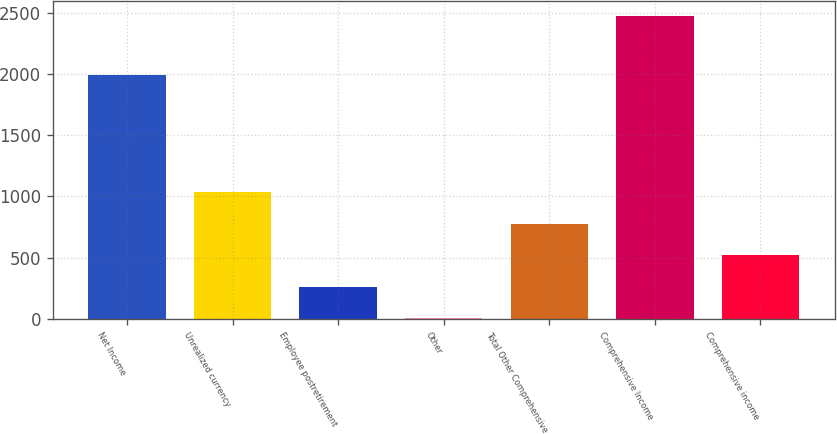Convert chart to OTSL. <chart><loc_0><loc_0><loc_500><loc_500><bar_chart><fcel>Net Income<fcel>Unrealized currency<fcel>Employee postretirement<fcel>Other<fcel>Total Other Comprehensive<fcel>Comprehensive Income<fcel>Comprehensive income<nl><fcel>1994<fcel>1037<fcel>261.5<fcel>3<fcel>778.5<fcel>2474<fcel>520<nl></chart> 